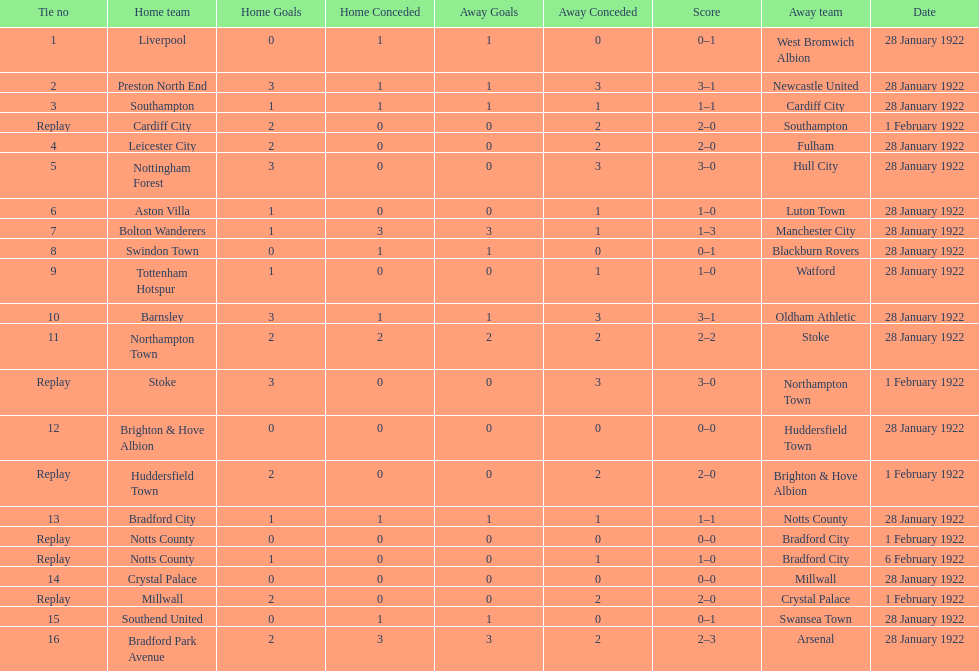Who is the first home team listed as having a score of 3-1? Preston North End. 